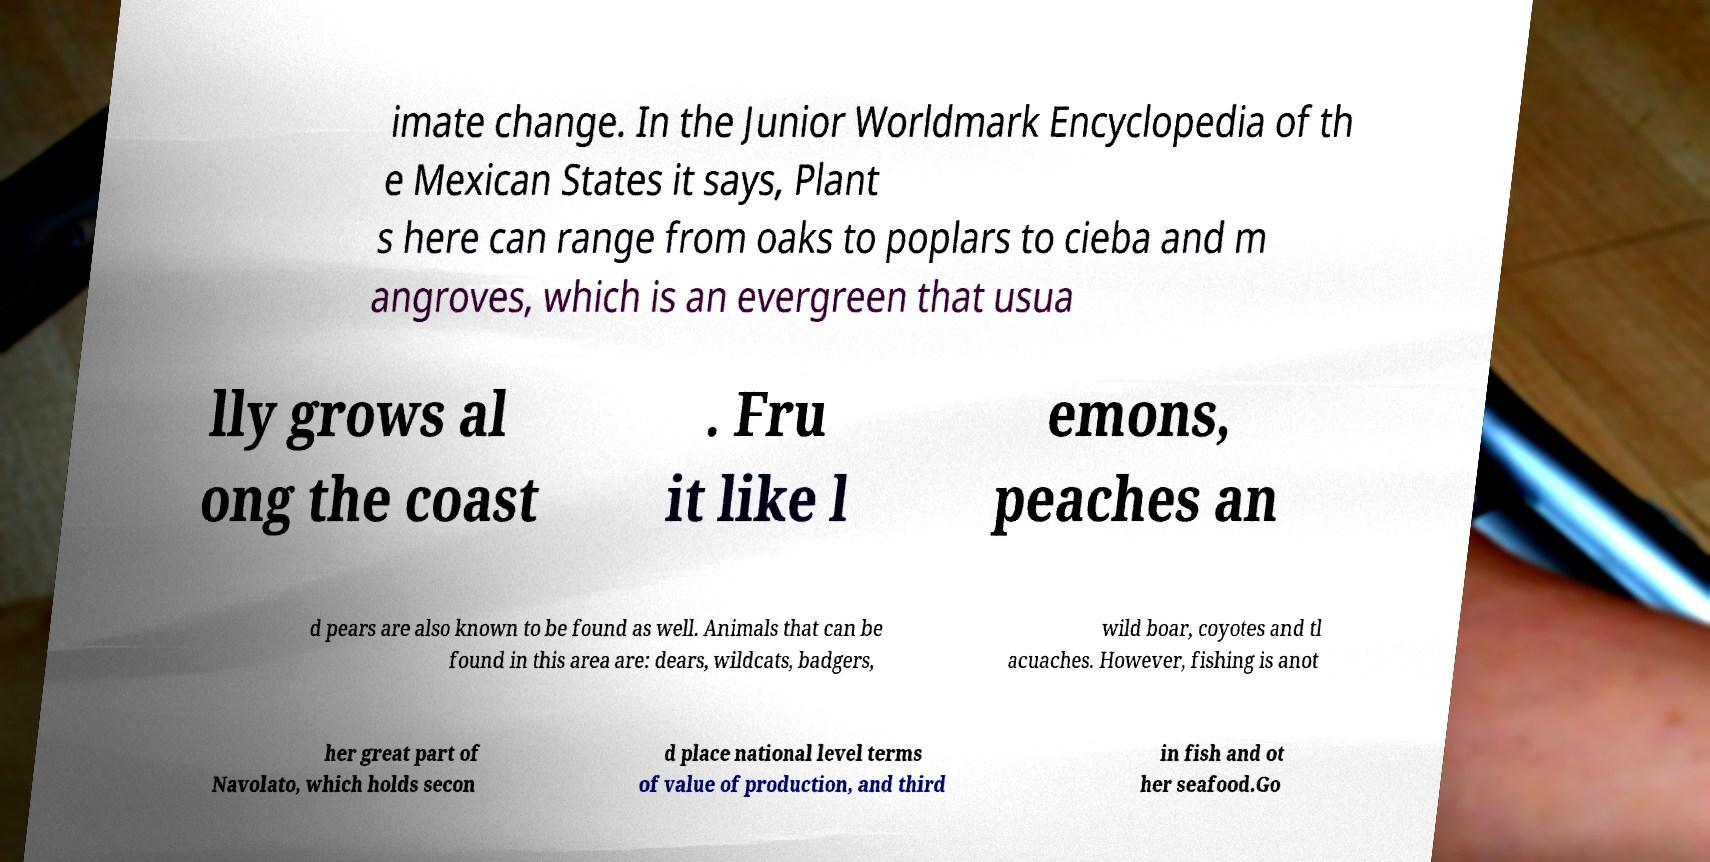Please identify and transcribe the text found in this image. imate change. In the Junior Worldmark Encyclopedia of th e Mexican States it says, Plant s here can range from oaks to poplars to cieba and m angroves, which is an evergreen that usua lly grows al ong the coast . Fru it like l emons, peaches an d pears are also known to be found as well. Animals that can be found in this area are: dears, wildcats, badgers, wild boar, coyotes and tl acuaches. However, fishing is anot her great part of Navolato, which holds secon d place national level terms of value of production, and third in fish and ot her seafood.Go 